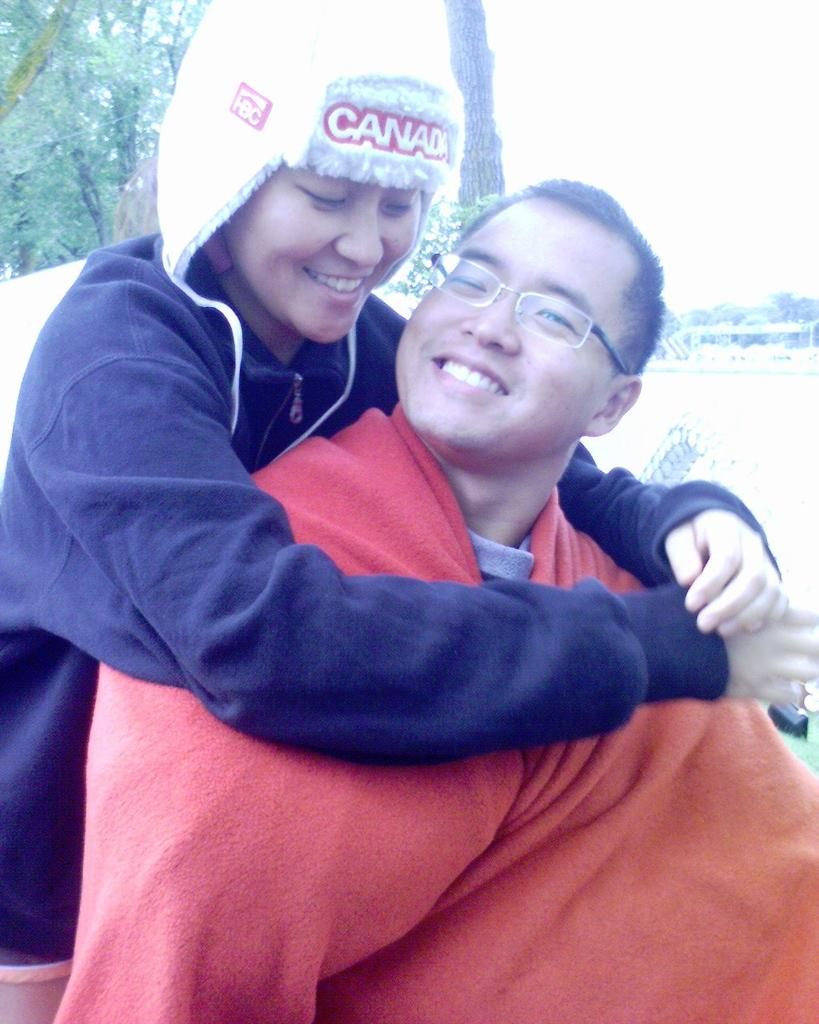How many people are in the image? There are two people in the image. What is the facial expression of the people in the image? The people are smiling. What type of vegetation can be seen in the background of the image? There are trees visible in the background of the image. What part of the natural environment is visible at the top of the image? The sky is visible at the top of the image. What type of ground surface is visible at the bottom of the image? There is grass visible at the bottom of the image. Can you see a spoon being used by the people in the image? There is no spoon visible in the image. Is there a rabbit hopping around the people in the image? There is no rabbit present in the image. 